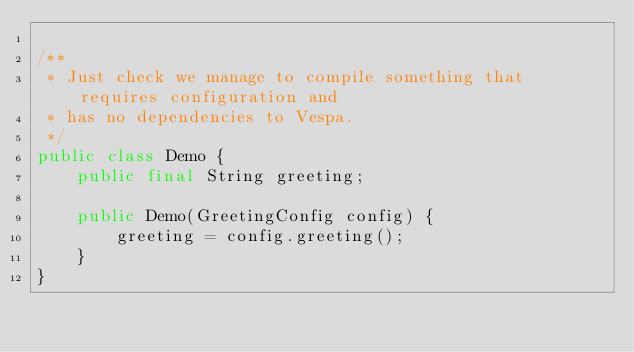Convert code to text. <code><loc_0><loc_0><loc_500><loc_500><_Java_>
/**
 * Just check we manage to compile something that requires configuration and
 * has no dependencies to Vespa.
 */
public class Demo {
    public final String greeting;

    public Demo(GreetingConfig config) {
        greeting = config.greeting();
    }
}
</code> 